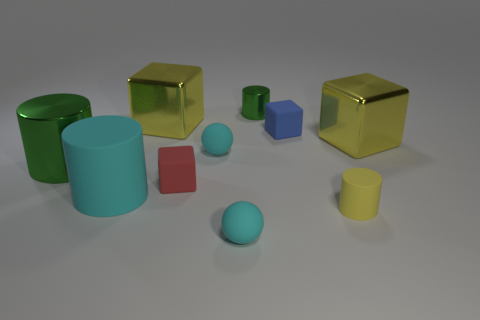Subtract 1 cubes. How many cubes are left? 3 Subtract all brown cubes. Subtract all yellow cylinders. How many cubes are left? 4 Add 6 tiny cyan rubber balls. How many tiny cyan rubber balls exist? 8 Subtract 0 brown spheres. How many objects are left? 10 Subtract all spheres. How many objects are left? 8 Subtract all small green metallic cylinders. Subtract all purple shiny blocks. How many objects are left? 9 Add 1 tiny blocks. How many tiny blocks are left? 3 